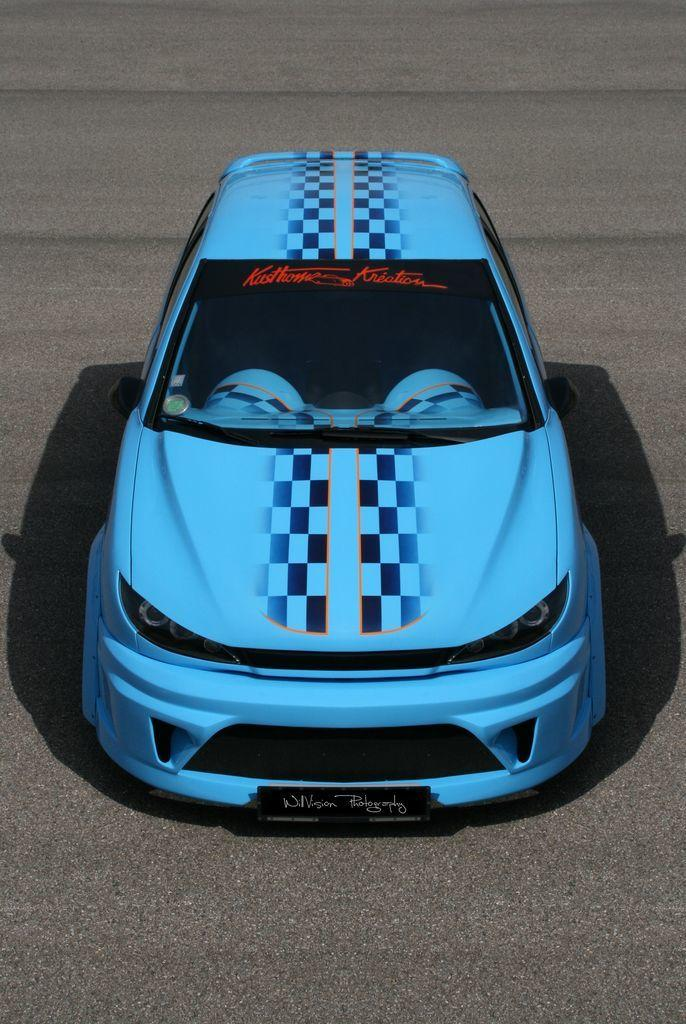What is the main subject of the image? There is a car in the image. Where is the car located? The car is on the road. Can you describe the style of the image? The image appears to be an animated photo. What type of boat can be seen in the image? There is no boat present in the image; it features a car on the road. What statement is being made by the car in the image? The car in the image is not making a statement, as it is an inanimate object. 